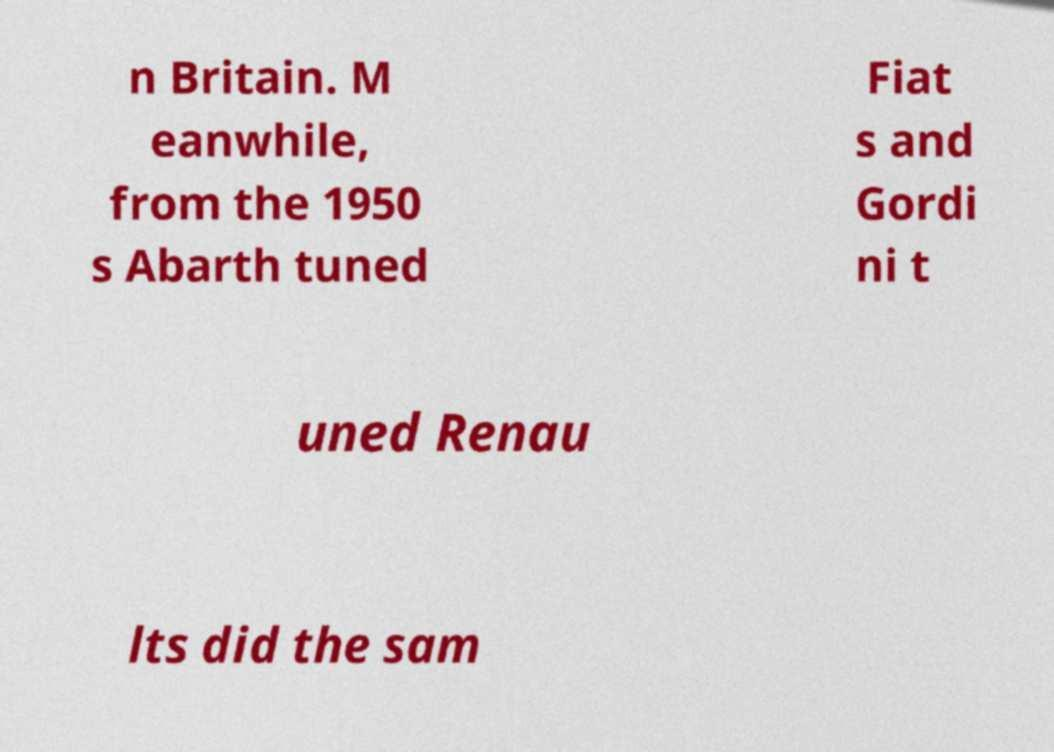Can you accurately transcribe the text from the provided image for me? n Britain. M eanwhile, from the 1950 s Abarth tuned Fiat s and Gordi ni t uned Renau lts did the sam 